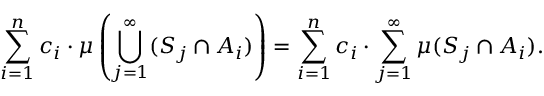Convert formula to latex. <formula><loc_0><loc_0><loc_500><loc_500>\sum _ { i = 1 } ^ { n } c _ { i } \cdot \mu \left ( \bigcup _ { j = 1 } ^ { \infty } ( S _ { j } \cap A _ { i } ) \right ) = \sum _ { i = 1 } ^ { n } c _ { i } \cdot \sum _ { j = 1 } ^ { \infty } \mu ( S _ { j } \cap A _ { i } ) .</formula> 